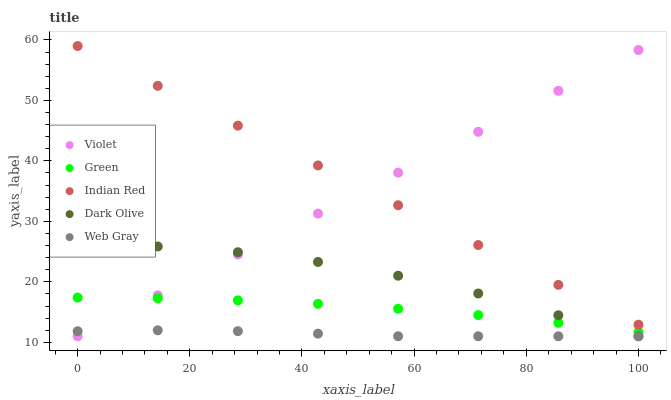Does Web Gray have the minimum area under the curve?
Answer yes or no. Yes. Does Indian Red have the maximum area under the curve?
Answer yes or no. Yes. Does Dark Olive have the minimum area under the curve?
Answer yes or no. No. Does Dark Olive have the maximum area under the curve?
Answer yes or no. No. Is Indian Red the smoothest?
Answer yes or no. Yes. Is Dark Olive the roughest?
Answer yes or no. Yes. Is Green the smoothest?
Answer yes or no. No. Is Green the roughest?
Answer yes or no. No. Does Web Gray have the lowest value?
Answer yes or no. Yes. Does Green have the lowest value?
Answer yes or no. No. Does Indian Red have the highest value?
Answer yes or no. Yes. Does Dark Olive have the highest value?
Answer yes or no. No. Is Green less than Indian Red?
Answer yes or no. Yes. Is Indian Red greater than Web Gray?
Answer yes or no. Yes. Does Violet intersect Dark Olive?
Answer yes or no. Yes. Is Violet less than Dark Olive?
Answer yes or no. No. Is Violet greater than Dark Olive?
Answer yes or no. No. Does Green intersect Indian Red?
Answer yes or no. No. 